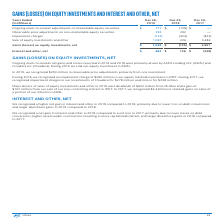According to Intel Corporation's financial document, What were the main drivers for the net gains and losses in ongoing mark-to-market in 2019 and 2018? Ongoing mark-to-market net gains and losses reported in 2019 and 2018 were primarily driven by ASML Holding N.V. (ASML) and Cloudera Inc. (Cloudera).. The document states: "Ongoing mark-to-market net gains and losses reported in 2019 and 2018 were primarily driven by ASML Holding N.V. (ASML) and Cloudera Inc. (Cloudera). ..." Also, What were the main reasons for a higher net gain in interest and other in 2019 compared to 2018? Higher net gain in interest and other in 2019 compared to 2018, primarily due to lower loss on debt conversions and larger divestiture gains in 2019 compared to 2018.. The document states: "We recognized a higher net gain in interest and other in 2019 compared to 2018, primarily due to lower loss on debt conversions and larger divestiture..." Also, What were the main reasons for a net gain in interest and other in 2018 compared to a net loss in 2017? A net gain in interest and other in 2018 compared to a net loss in 2017, primarily due to lower losses on debt conversions, higher assets under construction resulting in more capitalized interest, and larger divestiture gains in 2018 compared to 2017.. The document states: "We recognized a net gain in interest and other in 2018 compared to a net loss in 2017, primarily due to lower losses on debt conversions, higher asset..." Also, can you calculate: What is the proportion of equity method investment in IMFT in impairment charge in 2018? Based on the calculation: 290 / 424, the result is 68.4 (percentage). This is based on the information: "Impairment charges (122) (424) (833) ring 2018, we recognized an impairment charge of $290 million in our equity method investment in IMFT. During 2017, we recognized impairment charges in o..." The key data points involved are: 290, 424. Also, can you calculate: What is the proportion of dividends from McAfee in sales of equity investments and other in 2019? Based on the calculation: 632 / 1,091, the result is 57.93 (percentage). This is based on the information: "Sale of equity investments and other 1,091 226 3,484 investments and other in 2019 were dividends of $632 million from McAfee and a gain of $107 million from our sale of our non-controlling interest i..." The key data points involved are: 1,091, 632. Also, can you calculate: What is the percentage change in gains (losses) on equity investments, net from 2017 to 2019? To answer this question, I need to perform calculations using the financial data. The calculation is: (1,539 - 2,651) / 2,651, which equals -41.95 (percentage). This is based on the information: "Gains (losses) on equity investments, net $ 1,539 $ (125) $ 2,651 ses) on equity investments, net $ 1,539 $ (125) $ 2,651..." The key data points involved are: 1,539, 2,651. 